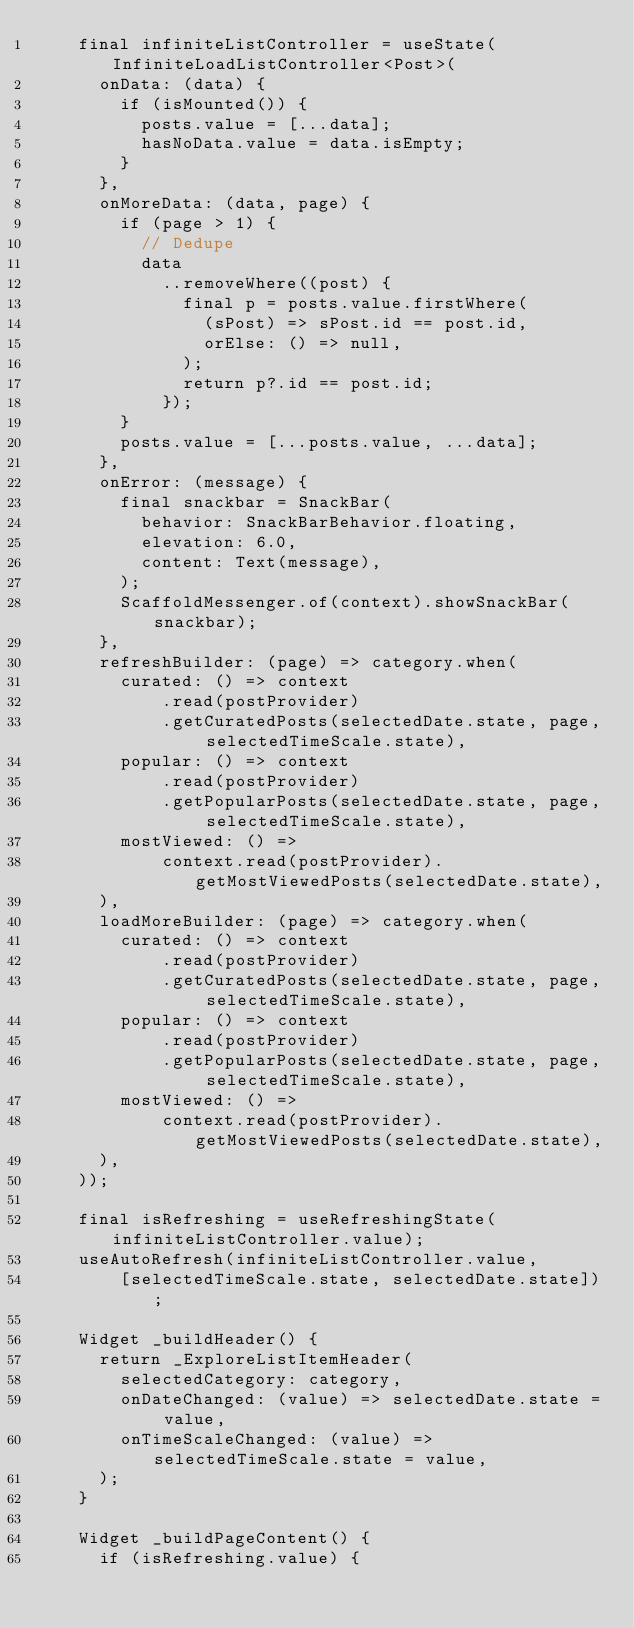Convert code to text. <code><loc_0><loc_0><loc_500><loc_500><_Dart_>    final infiniteListController = useState(InfiniteLoadListController<Post>(
      onData: (data) {
        if (isMounted()) {
          posts.value = [...data];
          hasNoData.value = data.isEmpty;
        }
      },
      onMoreData: (data, page) {
        if (page > 1) {
          // Dedupe
          data
            ..removeWhere((post) {
              final p = posts.value.firstWhere(
                (sPost) => sPost.id == post.id,
                orElse: () => null,
              );
              return p?.id == post.id;
            });
        }
        posts.value = [...posts.value, ...data];
      },
      onError: (message) {
        final snackbar = SnackBar(
          behavior: SnackBarBehavior.floating,
          elevation: 6.0,
          content: Text(message),
        );
        ScaffoldMessenger.of(context).showSnackBar(snackbar);
      },
      refreshBuilder: (page) => category.when(
        curated: () => context
            .read(postProvider)
            .getCuratedPosts(selectedDate.state, page, selectedTimeScale.state),
        popular: () => context
            .read(postProvider)
            .getPopularPosts(selectedDate.state, page, selectedTimeScale.state),
        mostViewed: () =>
            context.read(postProvider).getMostViewedPosts(selectedDate.state),
      ),
      loadMoreBuilder: (page) => category.when(
        curated: () => context
            .read(postProvider)
            .getCuratedPosts(selectedDate.state, page, selectedTimeScale.state),
        popular: () => context
            .read(postProvider)
            .getPopularPosts(selectedDate.state, page, selectedTimeScale.state),
        mostViewed: () =>
            context.read(postProvider).getMostViewedPosts(selectedDate.state),
      ),
    ));

    final isRefreshing = useRefreshingState(infiniteListController.value);
    useAutoRefresh(infiniteListController.value,
        [selectedTimeScale.state, selectedDate.state]);

    Widget _buildHeader() {
      return _ExploreListItemHeader(
        selectedCategory: category,
        onDateChanged: (value) => selectedDate.state = value,
        onTimeScaleChanged: (value) => selectedTimeScale.state = value,
      );
    }

    Widget _buildPageContent() {
      if (isRefreshing.value) {</code> 